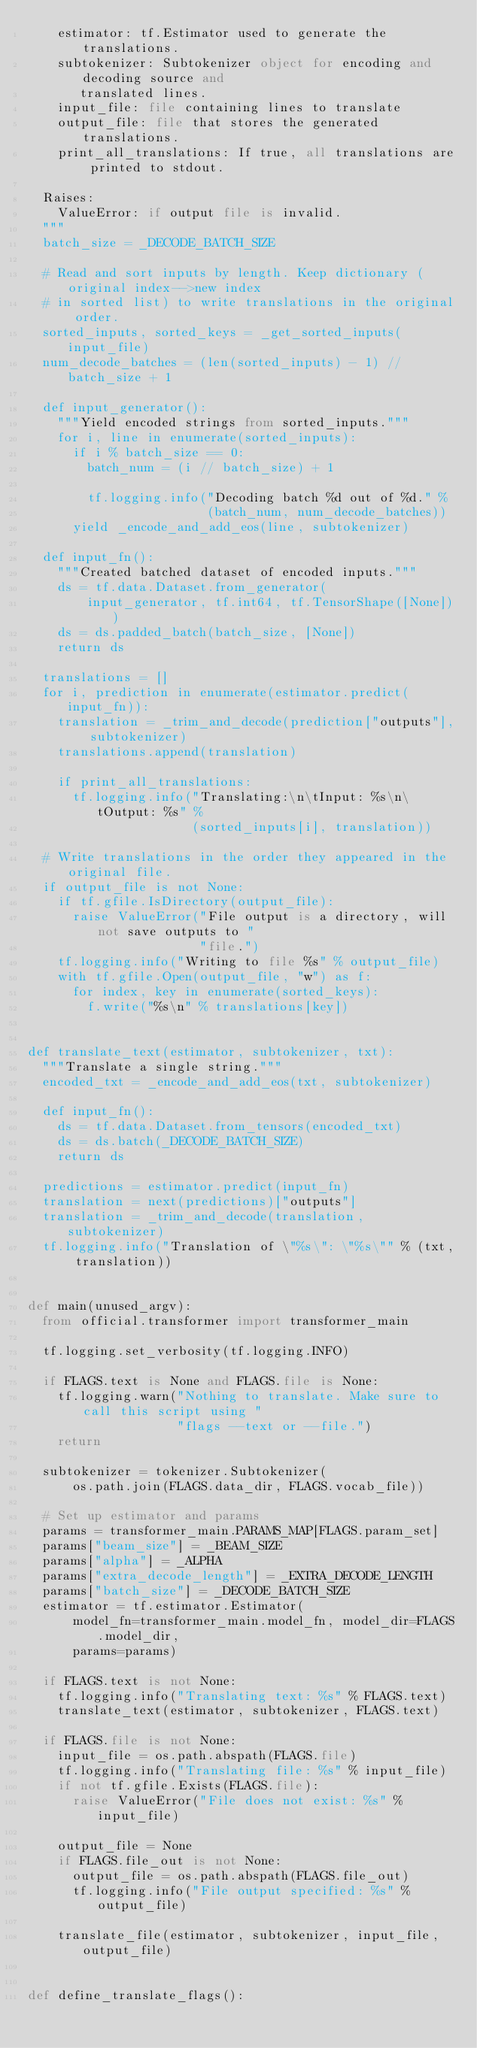<code> <loc_0><loc_0><loc_500><loc_500><_Python_>    estimator: tf.Estimator used to generate the translations.
    subtokenizer: Subtokenizer object for encoding and decoding source and
       translated lines.
    input_file: file containing lines to translate
    output_file: file that stores the generated translations.
    print_all_translations: If true, all translations are printed to stdout.

  Raises:
    ValueError: if output file is invalid.
  """
  batch_size = _DECODE_BATCH_SIZE

  # Read and sort inputs by length. Keep dictionary (original index-->new index
  # in sorted list) to write translations in the original order.
  sorted_inputs, sorted_keys = _get_sorted_inputs(input_file)
  num_decode_batches = (len(sorted_inputs) - 1) // batch_size + 1

  def input_generator():
    """Yield encoded strings from sorted_inputs."""
    for i, line in enumerate(sorted_inputs):
      if i % batch_size == 0:
        batch_num = (i // batch_size) + 1

        tf.logging.info("Decoding batch %d out of %d." %
                        (batch_num, num_decode_batches))
      yield _encode_and_add_eos(line, subtokenizer)

  def input_fn():
    """Created batched dataset of encoded inputs."""
    ds = tf.data.Dataset.from_generator(
        input_generator, tf.int64, tf.TensorShape([None]))
    ds = ds.padded_batch(batch_size, [None])
    return ds

  translations = []
  for i, prediction in enumerate(estimator.predict(input_fn)):
    translation = _trim_and_decode(prediction["outputs"], subtokenizer)
    translations.append(translation)

    if print_all_translations:
      tf.logging.info("Translating:\n\tInput: %s\n\tOutput: %s" %
                      (sorted_inputs[i], translation))

  # Write translations in the order they appeared in the original file.
  if output_file is not None:
    if tf.gfile.IsDirectory(output_file):
      raise ValueError("File output is a directory, will not save outputs to "
                       "file.")
    tf.logging.info("Writing to file %s" % output_file)
    with tf.gfile.Open(output_file, "w") as f:
      for index, key in enumerate(sorted_keys):
        f.write("%s\n" % translations[key])


def translate_text(estimator, subtokenizer, txt):
  """Translate a single string."""
  encoded_txt = _encode_and_add_eos(txt, subtokenizer)

  def input_fn():
    ds = tf.data.Dataset.from_tensors(encoded_txt)
    ds = ds.batch(_DECODE_BATCH_SIZE)
    return ds

  predictions = estimator.predict(input_fn)
  translation = next(predictions)["outputs"]
  translation = _trim_and_decode(translation, subtokenizer)
  tf.logging.info("Translation of \"%s\": \"%s\"" % (txt, translation))


def main(unused_argv):
  from official.transformer import transformer_main

  tf.logging.set_verbosity(tf.logging.INFO)

  if FLAGS.text is None and FLAGS.file is None:
    tf.logging.warn("Nothing to translate. Make sure to call this script using "
                    "flags --text or --file.")
    return

  subtokenizer = tokenizer.Subtokenizer(
      os.path.join(FLAGS.data_dir, FLAGS.vocab_file))

  # Set up estimator and params
  params = transformer_main.PARAMS_MAP[FLAGS.param_set]
  params["beam_size"] = _BEAM_SIZE
  params["alpha"] = _ALPHA
  params["extra_decode_length"] = _EXTRA_DECODE_LENGTH
  params["batch_size"] = _DECODE_BATCH_SIZE
  estimator = tf.estimator.Estimator(
      model_fn=transformer_main.model_fn, model_dir=FLAGS.model_dir,
      params=params)

  if FLAGS.text is not None:
    tf.logging.info("Translating text: %s" % FLAGS.text)
    translate_text(estimator, subtokenizer, FLAGS.text)

  if FLAGS.file is not None:
    input_file = os.path.abspath(FLAGS.file)
    tf.logging.info("Translating file: %s" % input_file)
    if not tf.gfile.Exists(FLAGS.file):
      raise ValueError("File does not exist: %s" % input_file)

    output_file = None
    if FLAGS.file_out is not None:
      output_file = os.path.abspath(FLAGS.file_out)
      tf.logging.info("File output specified: %s" % output_file)

    translate_file(estimator, subtokenizer, input_file, output_file)


def define_translate_flags():</code> 